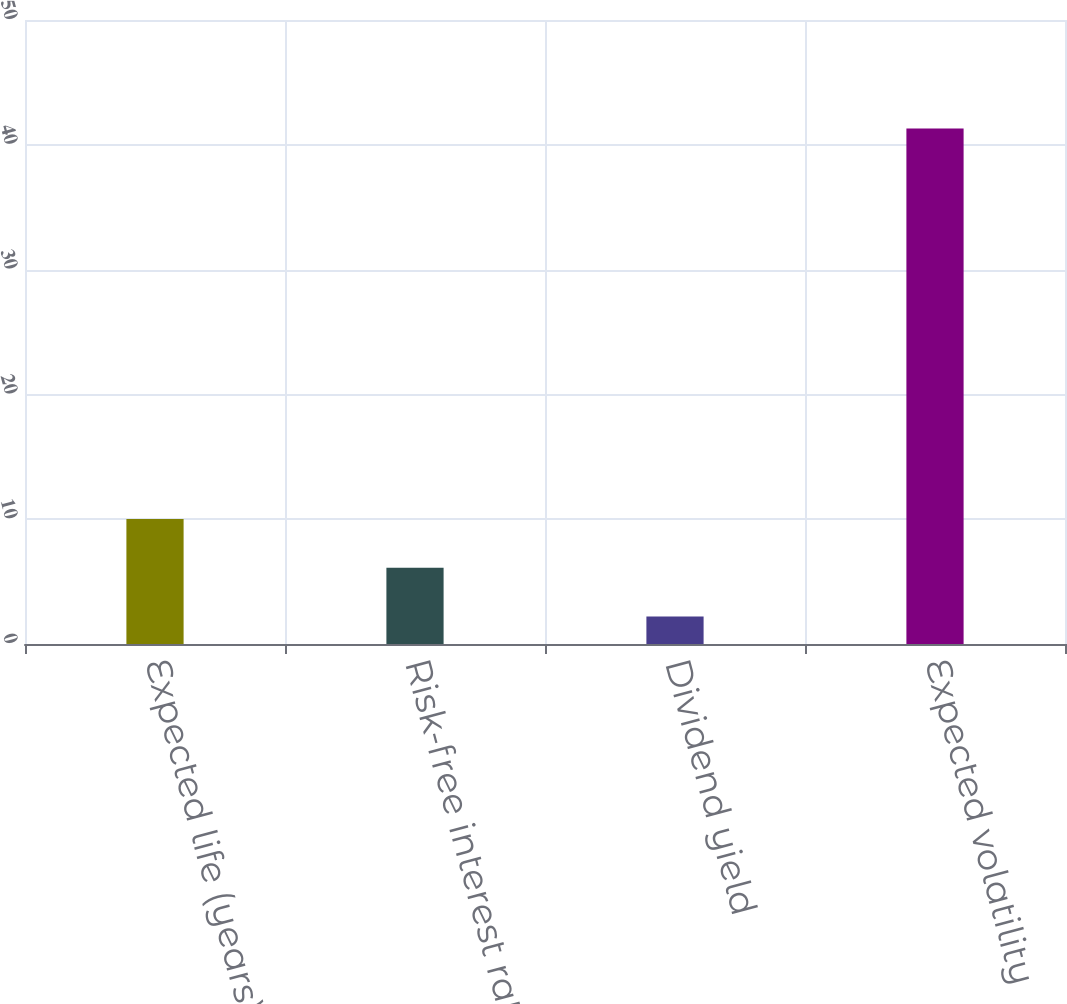Convert chart. <chart><loc_0><loc_0><loc_500><loc_500><bar_chart><fcel>Expected life (years)<fcel>Risk-free interest rate<fcel>Dividend yield<fcel>Expected volatility<nl><fcel>10.02<fcel>6.11<fcel>2.2<fcel>41.3<nl></chart> 